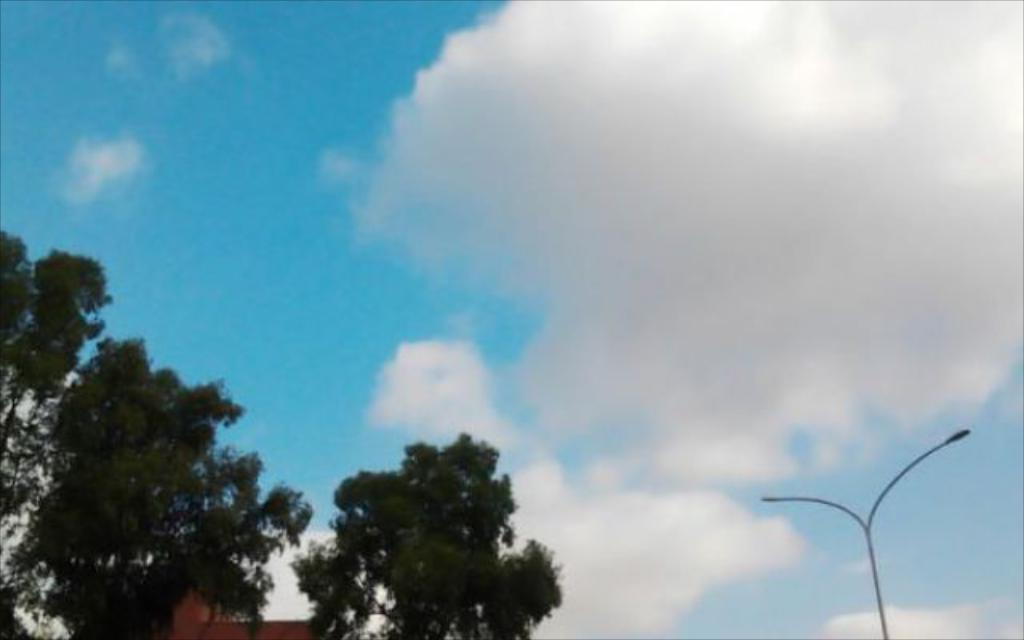What structure can be seen in the picture? There is a street light pole in the picture. What else is present in the picture besides the street light pole? There is a building in the picture. What is the condition of the sky in the picture? The sky is clear in the picture. What is the taste of the ocean in the picture? There is no ocean present in the picture, so it is not possible to determine its taste. 